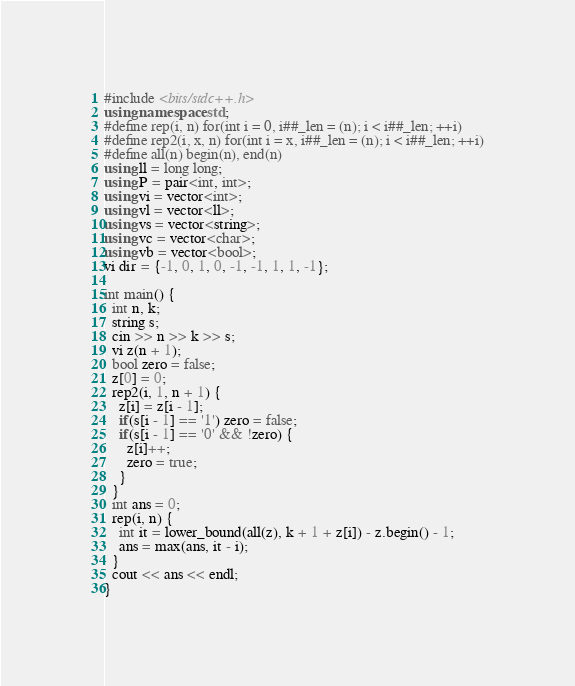<code> <loc_0><loc_0><loc_500><loc_500><_C++_>#include <bits/stdc++.h>
using namespace std;
#define rep(i, n) for(int i = 0, i##_len = (n); i < i##_len; ++i)
#define rep2(i, x, n) for(int i = x, i##_len = (n); i < i##_len; ++i)
#define all(n) begin(n), end(n)
using ll = long long;
using P = pair<int, int>;
using vi = vector<int>;
using vl = vector<ll>;
using vs = vector<string>;
using vc = vector<char>;
using vb = vector<bool>;
vi dir = {-1, 0, 1, 0, -1, -1, 1, 1, -1};

int main() {
  int n, k;
  string s;
  cin >> n >> k >> s;
  vi z(n + 1);
  bool zero = false;
  z[0] = 0;
  rep2(i, 1, n + 1) {
    z[i] = z[i - 1];
    if(s[i - 1] == '1') zero = false;
    if(s[i - 1] == '0' && !zero) {
      z[i]++;
      zero = true;
    }
  }
  int ans = 0;
  rep(i, n) {
    int it = lower_bound(all(z), k + 1 + z[i]) - z.begin() - 1;
    ans = max(ans, it - i);
  }
  cout << ans << endl;
}</code> 